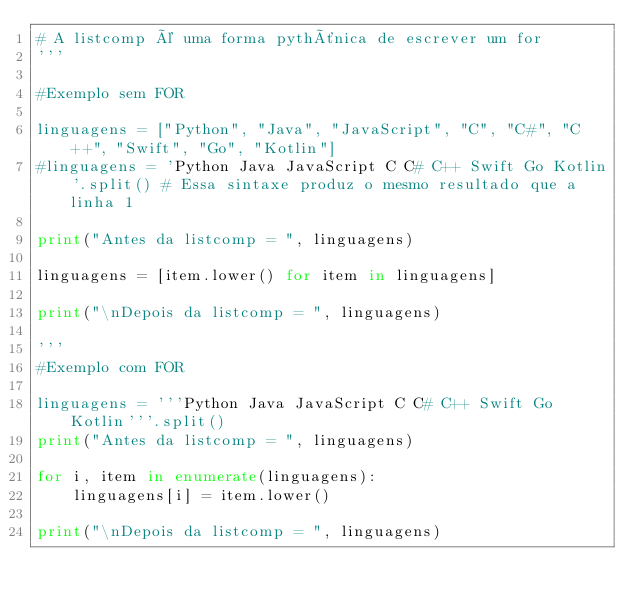<code> <loc_0><loc_0><loc_500><loc_500><_Python_># A listcomp é uma forma pythônica de escrever um for
'''

#Exemplo sem FOR

linguagens = ["Python", "Java", "JavaScript", "C", "C#", "C++", "Swift", "Go", "Kotlin"]
#linguagens = 'Python Java JavaScript C C# C++ Swift Go Kotlin'.split() # Essa sintaxe produz o mesmo resultado que a linha 1

print("Antes da listcomp = ", linguagens)

linguagens = [item.lower() for item in linguagens]

print("\nDepois da listcomp = ", linguagens)

'''
#Exemplo com FOR 

linguagens = '''Python Java JavaScript C C# C++ Swift Go Kotlin'''.split()
print("Antes da listcomp = ", linguagens)

for i, item in enumerate(linguagens):
    linguagens[i] = item.lower()
    
print("\nDepois da listcomp = ", linguagens)</code> 